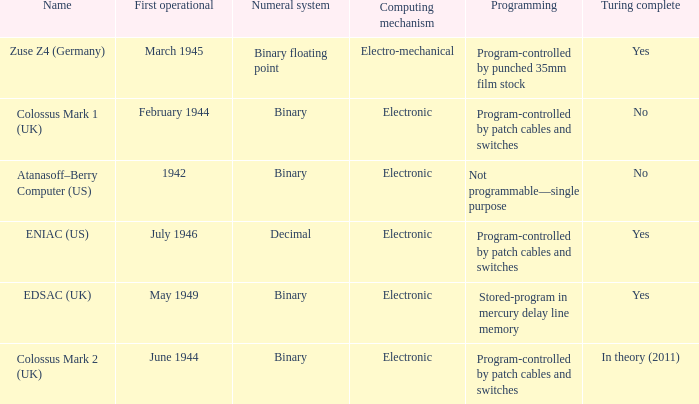What's the first operational with programming being not programmable—single purpose 1942.0. 